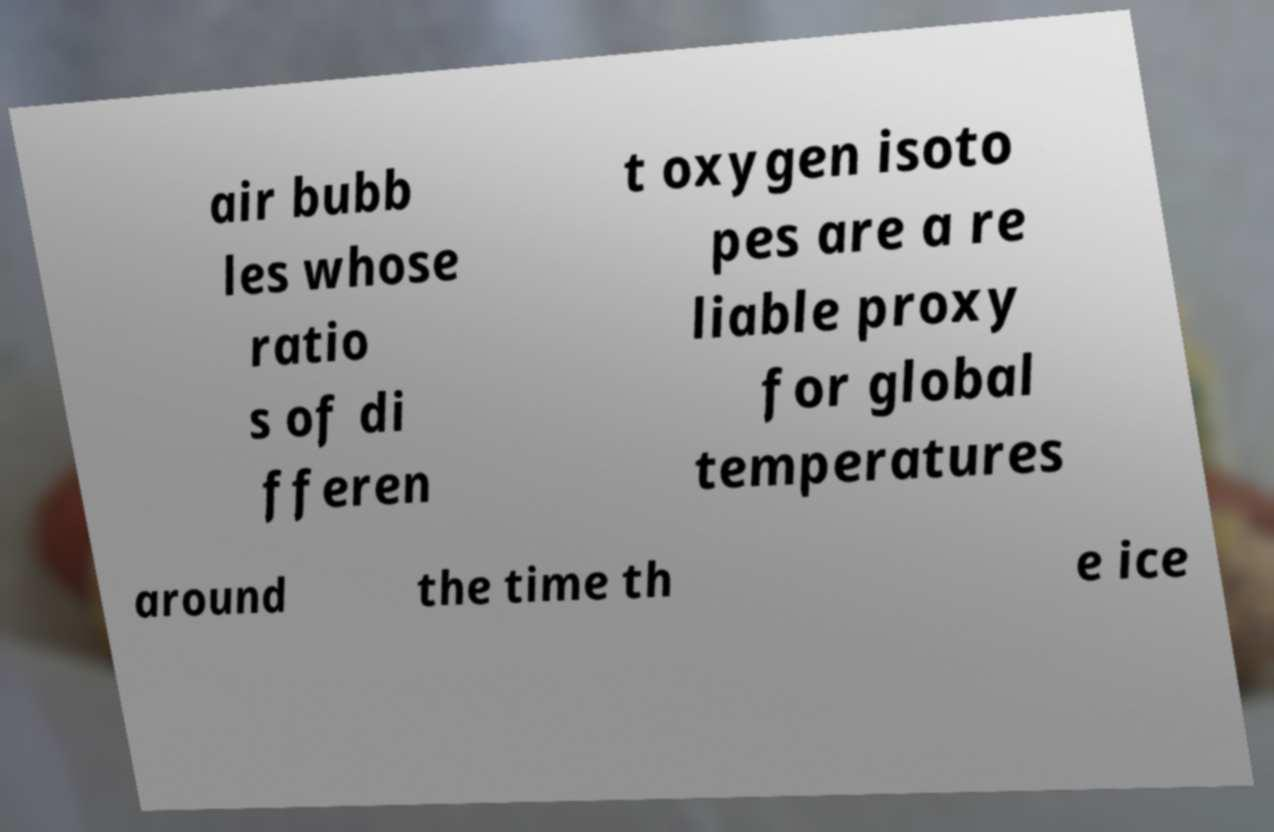There's text embedded in this image that I need extracted. Can you transcribe it verbatim? air bubb les whose ratio s of di fferen t oxygen isoto pes are a re liable proxy for global temperatures around the time th e ice 